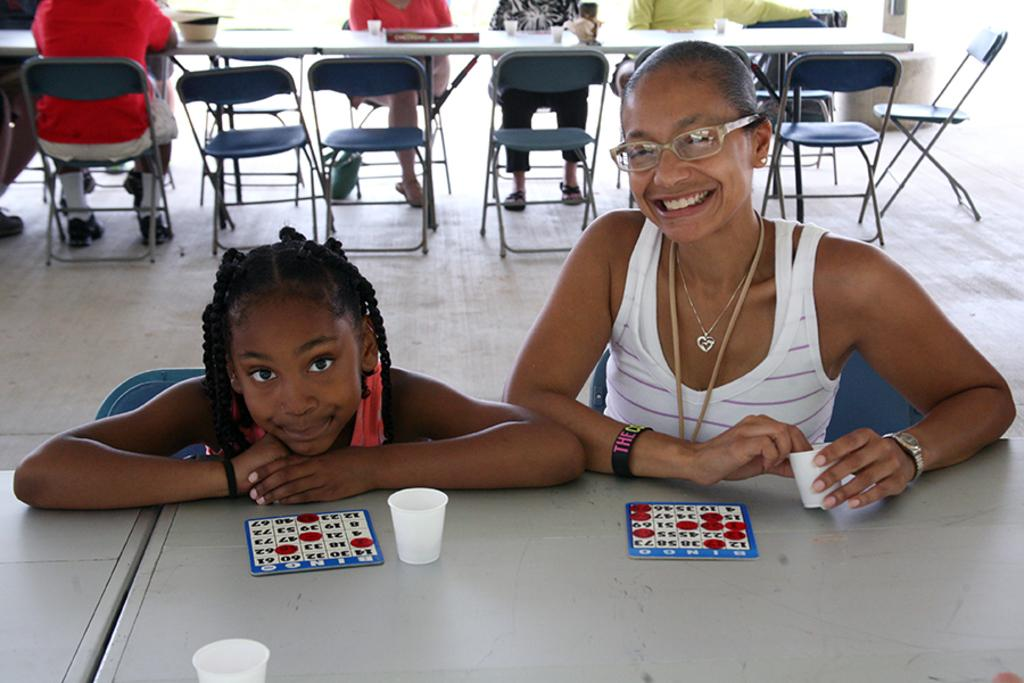What are the people in the image doing? The people in the image are sitting on chairs. What is present on the table in the image? There is a table in the image, and on it, there are cards and glasses. What type of magic trick is being performed with the cards in the image? There is no indication of a magic trick being performed in the image; it simply shows cards on a table. 